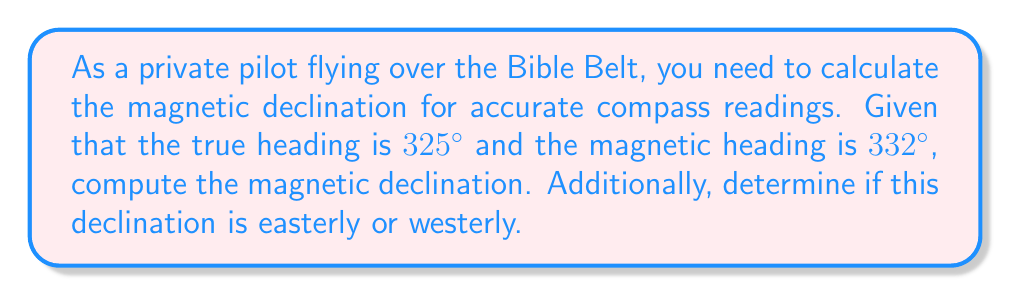Could you help me with this problem? To solve this problem, we'll follow these steps:

1) Recall that magnetic declination is the angle between true north and magnetic north. It's calculated as:

   $\text{Magnetic Declination} = \text{Magnetic Heading} - \text{True Heading}$

2) Let's substitute our given values:

   $\text{Magnetic Declination} = 332° - 325° = 7°$

3) The positive result indicates that the magnetic heading is greater than the true heading. This means the magnetic north is east of true north.

4) Therefore, the declination is 7° East or 7°E.

5) As a pilot, you would need to subtract this declination from your magnetic compass reading to get the true heading.

Remember, "East is least, West is best" - for easterly declination, subtract from the magnetic heading to get true heading; for westerly, add to the magnetic heading.
Answer: 7°E 